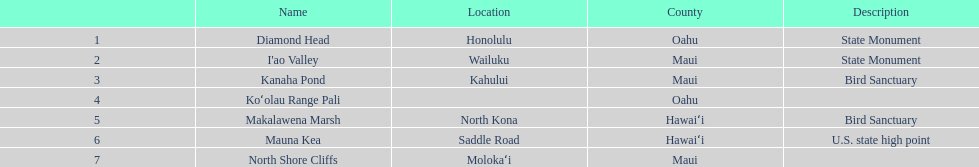Is kanaha pond a state monument or a bird sanctuary? Bird Sanctuary. 